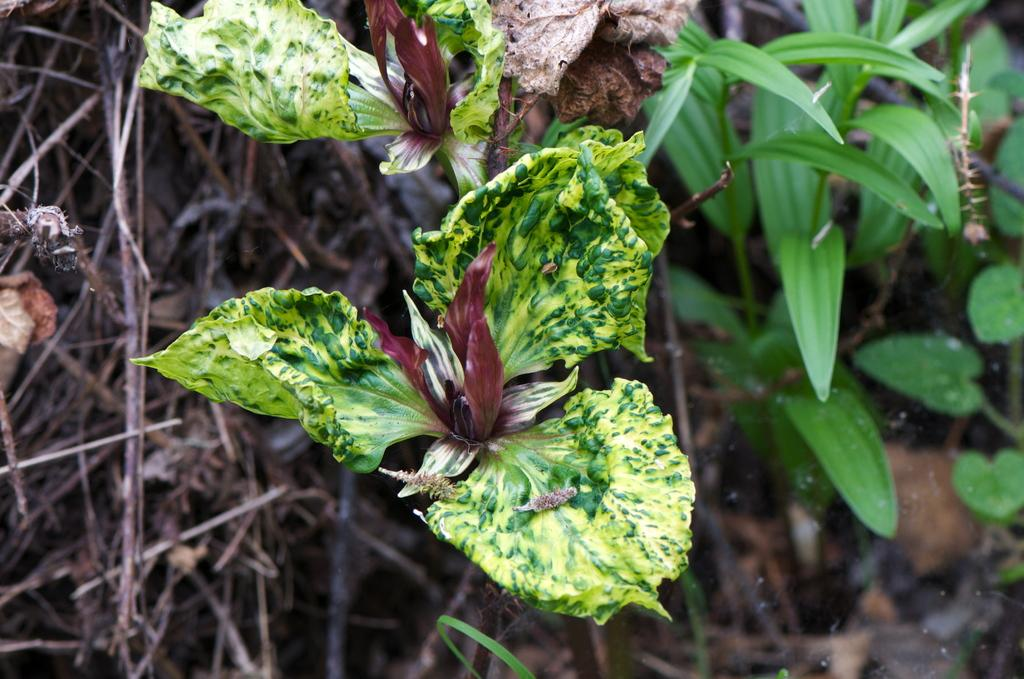What type of natural materials can be seen in the image? There are dried twigs and leaves in the image. What type of living organisms are present in the image? There are plants in the image. What color are the leaves of the plants in the image? The plants have green leaves. What type of bean is growing on the plants in the image? There are no beans visible in the image, and the plants are not identified as bean plants. 